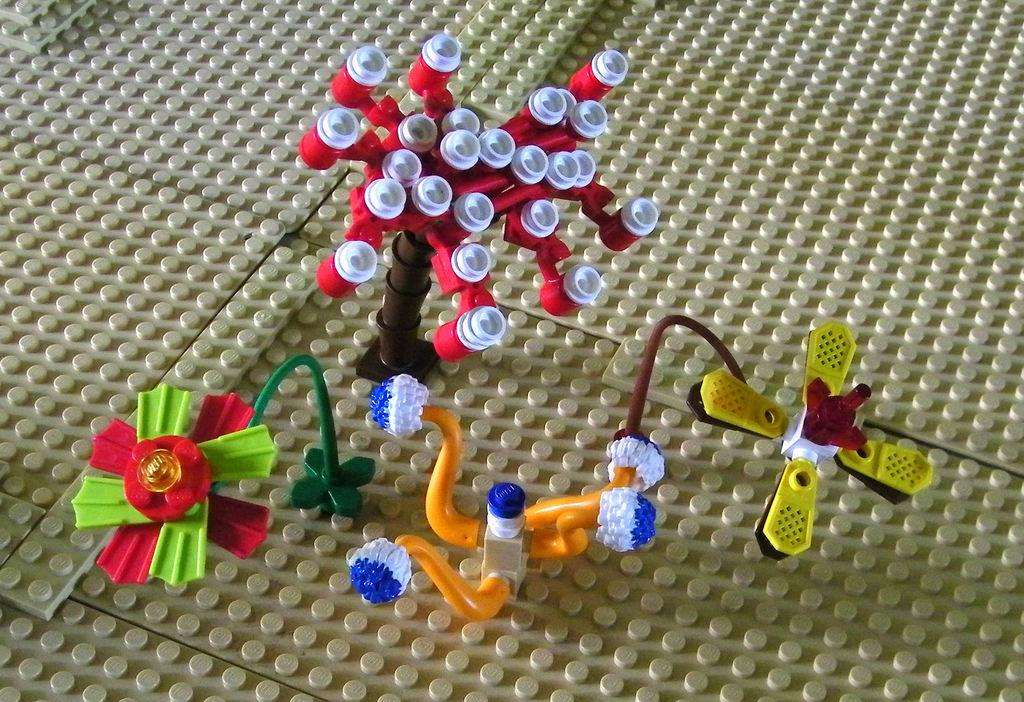What type of toys are in the image? There are Lego toys in the image. What shapes can be identified among the Lego toys? The Lego toys are shaped like a tree, a flower, and a fan. Are there any other shapes among the Lego toys? Yes, there are other unspecified shapes among the Lego toys. How many holes are there in the Lego tree? There are no holes mentioned in the Lego tree or any other Lego toys in the image. 